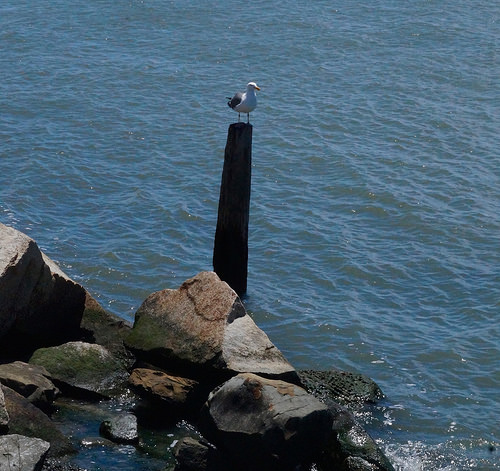<image>
Can you confirm if the wooden post is in the water? Yes. The wooden post is contained within or inside the water, showing a containment relationship. 